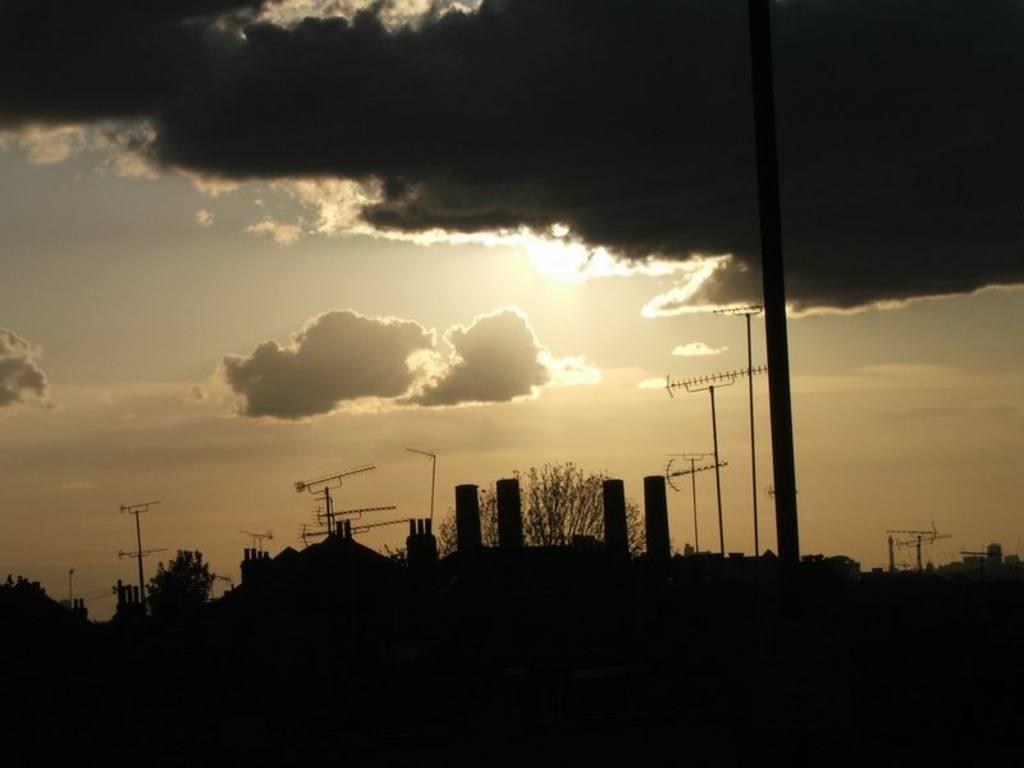Could you give a brief overview of what you see in this image? In this picture we can see there are some electrical poles and trees, clouds in the sky. 